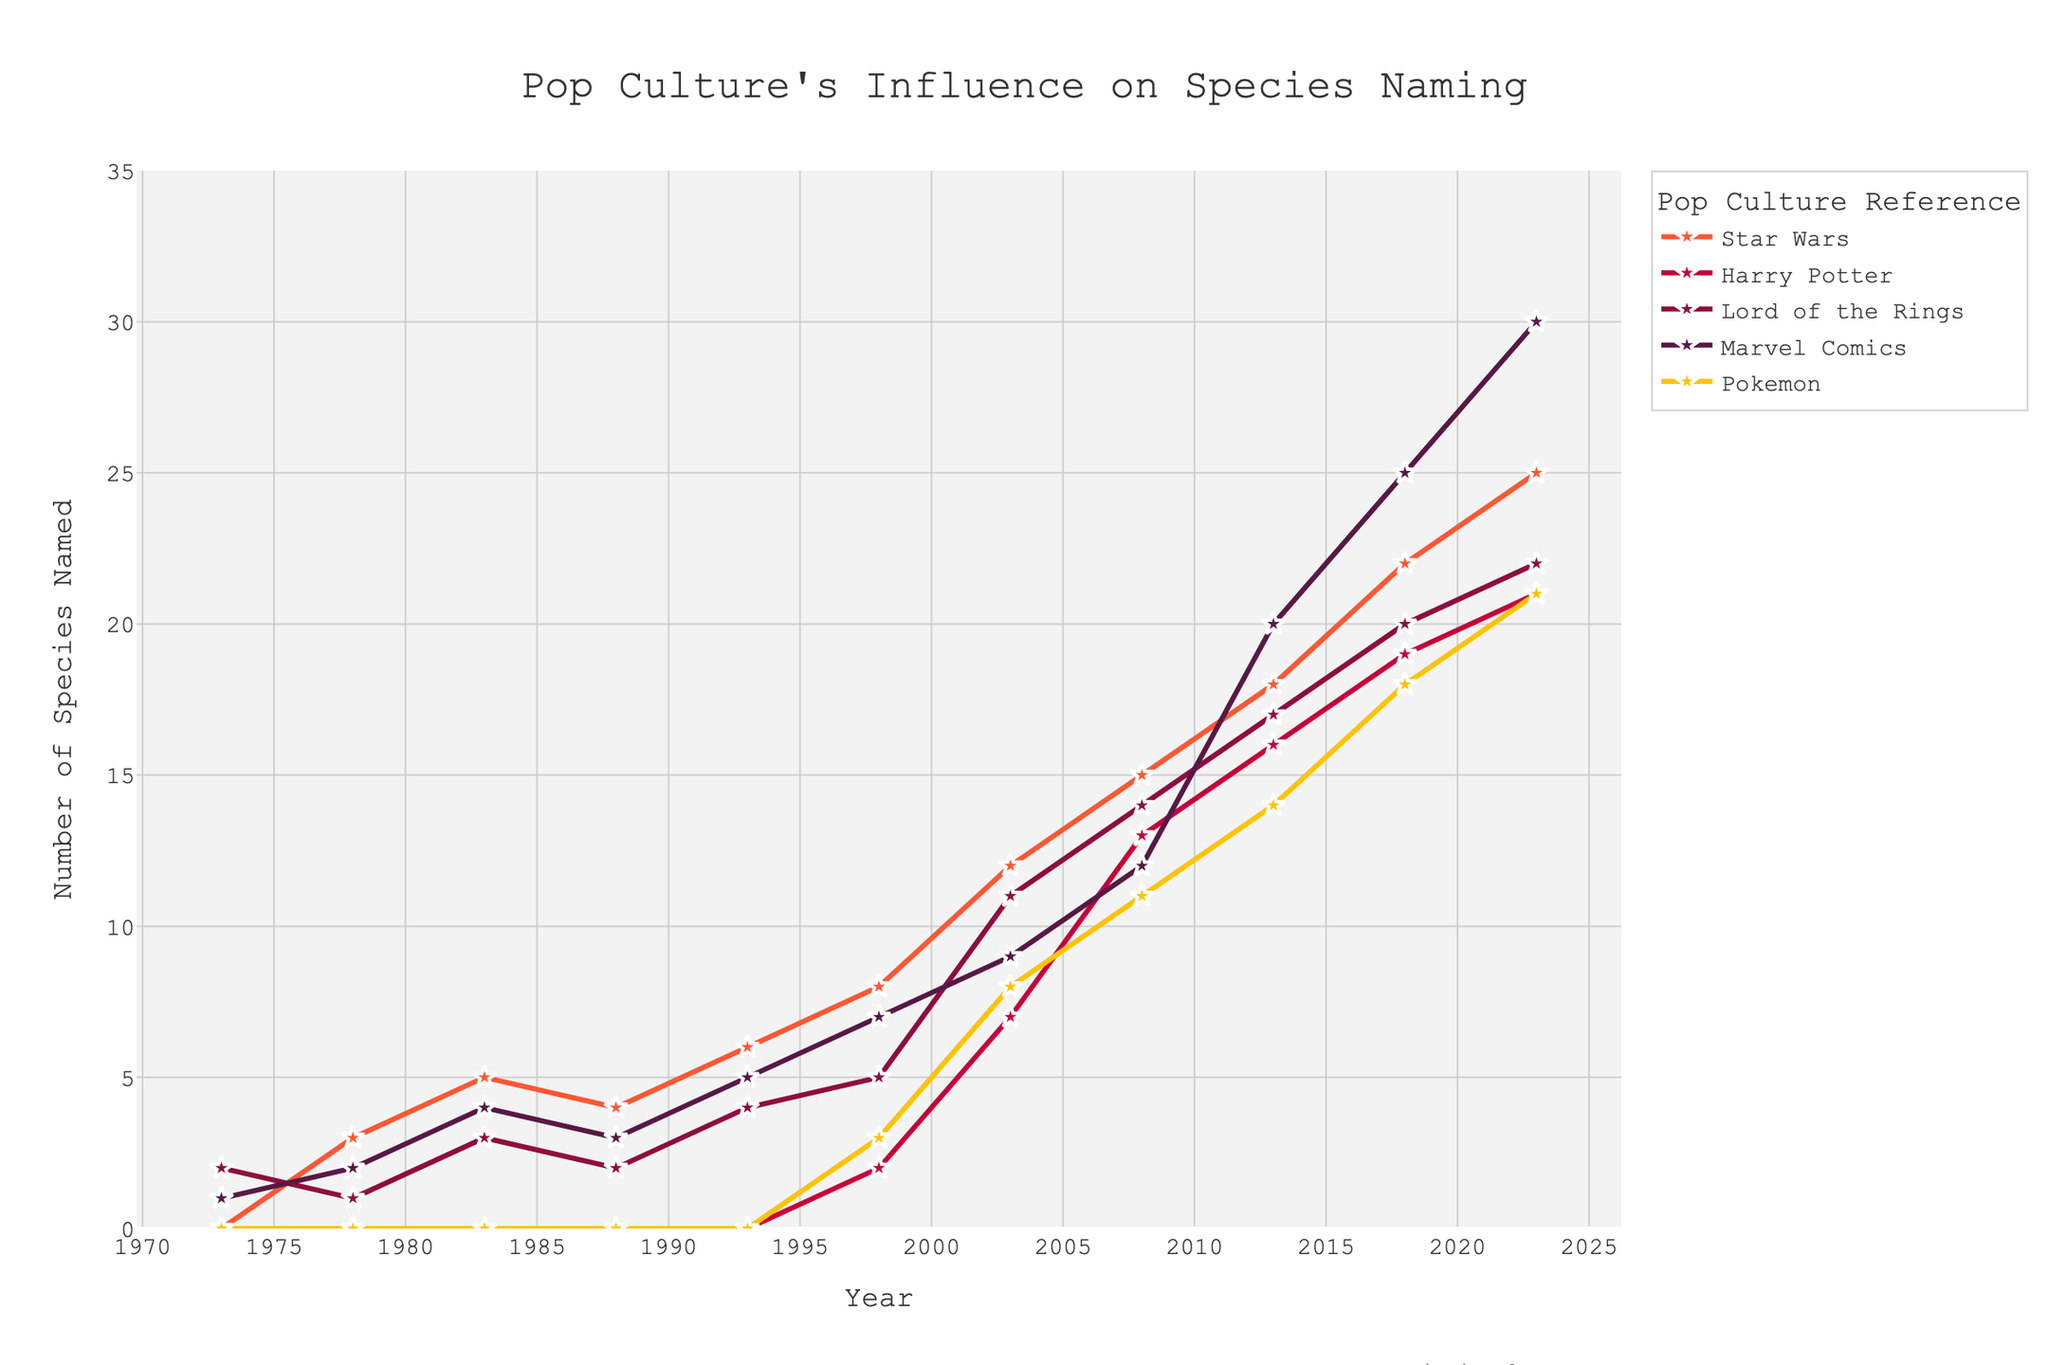How many species were named after Marvel Comics and Harry Potter combined in 2023? Add the number of species named after Marvel Comics in 2023 (30) with those named after Harry Potter (21). The sum is 30 + 21 = 51.
Answer: 51 Which pop culture reference had the most significant increase in species names from 2003 to 2023? Calculate the difference for each reference between 2023 and 2003, then compare these differences. Harry Potter: 21 - 7 = 14, Star Wars: 25 - 12 = 13, Lord of the Rings: 22 - 11 = 11, Marvel Comics: 30 - 9 = 21, Pokemon: 21 - 8 = 13. The most significant increase is for Marvel Comics, with an increase of 21.
Answer: Marvel Comics Between 1978 and 1983, which pop culture reference had the highest number of species named after it? Compare the number of species named after each reference in 1978 and 1983. In 1983: Star Wars (5), Harry Potter (0), Lord of the Rings (3), Marvel Comics (4), and Pokemon (0). Star Wars had the highest number, with 5 species names.
Answer: Star Wars What's the overall trend of species named after Pokemon from 1998 to 2023? Observe the values from 1998 to 2023 for Pokemon: 1998 (3), 2003 (8), 2008 (11), 2013 (14), 2018 (18), and 2023 (21). The trend shows a consistent increase in species named after Pokemon over the years.
Answer: Increasing Among all the references, which one had the least overall growth from 1973 to 2023? Compute the overall growth (difference between 2023 and 1973) for each reference. Star Wars: 25 - 0 = 25, Harry Potter: 21 - 0 = 21, Lord of the Rings: 22 - 2 = 20, Marvel Comics: 30 - 1 = 29, Pokemon: 21 - 0 = 21. Lord of the Rings had the least growth, with an increase of 20.
Answer: Lord of the Rings 